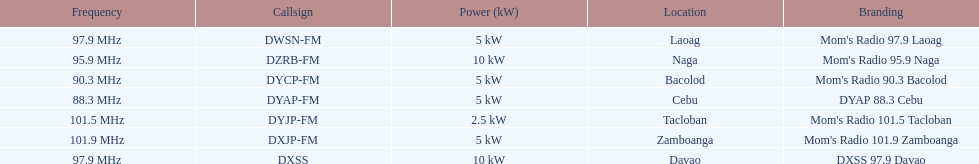What is the radio with the least about of mhz? DYAP 88.3 Cebu. 